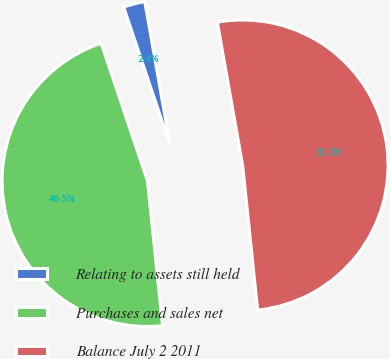Convert chart. <chart><loc_0><loc_0><loc_500><loc_500><pie_chart><fcel>Relating to assets still held<fcel>Purchases and sales net<fcel>Balance July 2 2011<nl><fcel>2.38%<fcel>46.49%<fcel>51.14%<nl></chart> 